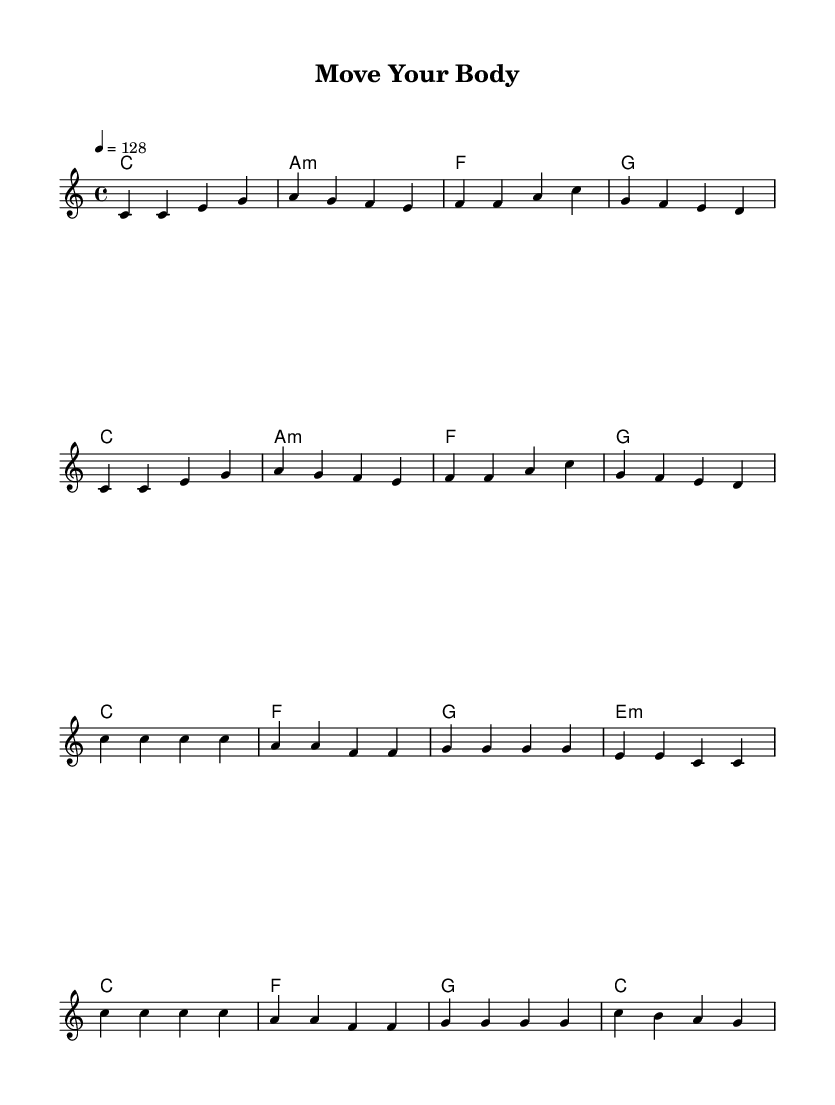What is the key signature of this music? The key signature is C major, which consists of no sharps or flats. This can be identified by looking at the section at the beginning where the key signature is indicated.
Answer: C major What is the time signature of this music? The time signature of this music is 4/4, which means there are four beats in each measure and the quarter note gets one beat. This is specified at the start of the sheet music.
Answer: 4/4 What is the tempo marking for this piece? The tempo marking is 128 beats per minute, indicated by "4 = 128" in the tempo section of the sheet music. This tells us how fast the music should be played.
Answer: 128 How many measures are there in the verse section? The verse section contains 8 measures, which can be counted by identifying the segments separated by vertical lines in the melody staff.
Answer: 8 What is the first chord used in the chorus? The first chord used in the chorus is C major, which can be identified in the chord names above the melody that correspond to the beginning of the chorus section.
Answer: C What melodic motif is repeated in the chorus? The melodic motif repeated in the chorus is "c c c c," which appears prominently at the start of the chorus section. This repetition creates a strong hook typical in pop music.
Answer: c c c c Which chord follows the A minor chord in the verse? The chord that follows the A minor chord is F major, which can be seen by looking at the progression of the chord names beneath the melody in the verse section.
Answer: F 